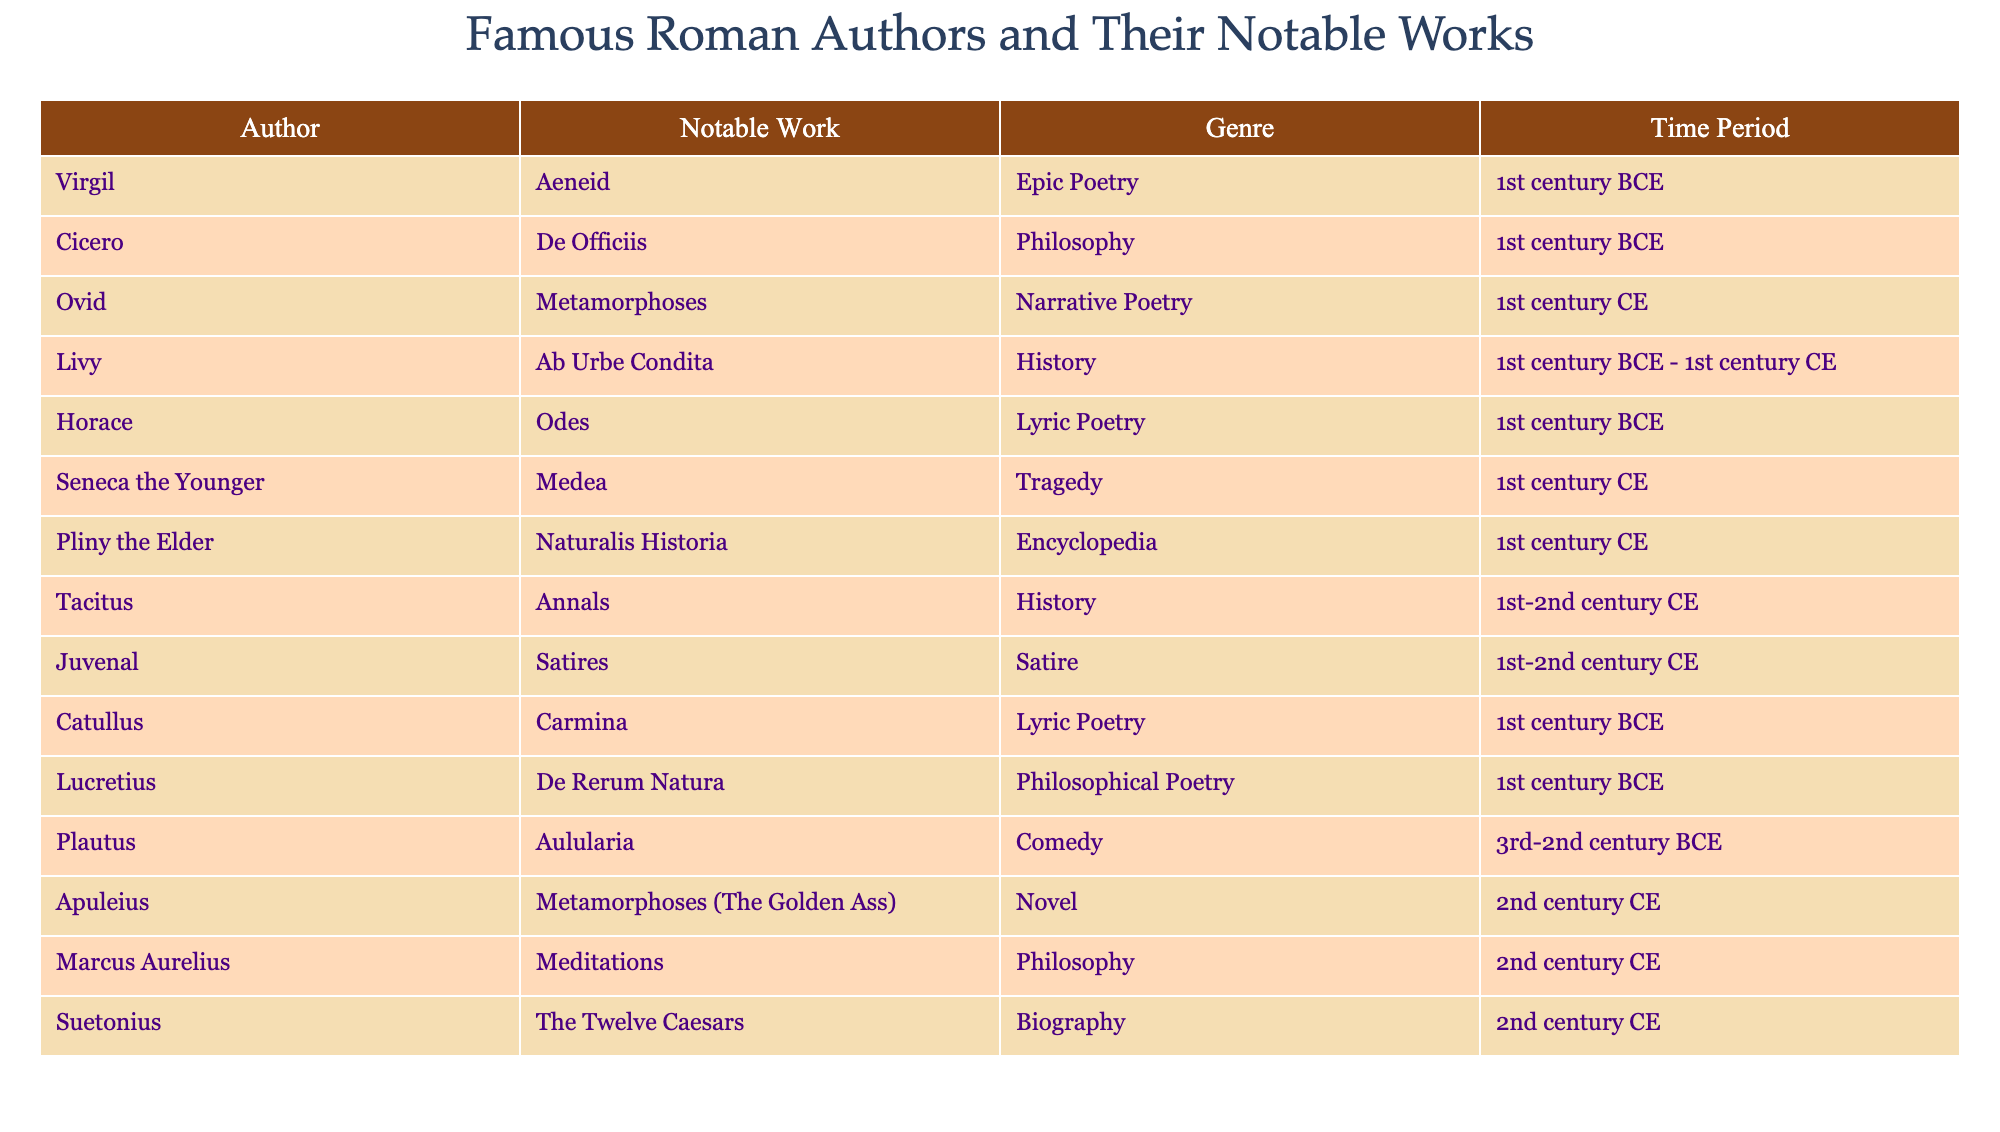What is the notable work of Virgil? The table lists the notable work associated with each author, and for Virgil, it is specifically mentioned as "Aeneid."
Answer: Aeneid Which genre does Ovid's notable work belong to? Referring to the genre column, Ovid's notable work "Metamorphoses" falls under the category "Narrative Poetry."
Answer: Narrative Poetry How many authors wrote works in the genre of Philosophy? By counting the entries in the genre column, we find that both Cicero and Marcus Aurelius are in the Philosophy category, making a total of 2 authors.
Answer: 2 Is Livy's notable work a biography? Looking at the notable work column for Livy, it states "Ab Urbe Condita," which is classified as History, not Biography, making this statement false.
Answer: No Which author has a notable work that is categorized as comedy? Referencing the table, the author Plautus is indicated as having the notable work "Aulularia," which is classified under Comedy.
Answer: Plautus What is the time period of Seneca the Younger? The table provides the time period for Seneca the Younger, which is given as "1st century CE," directly answering the question.
Answer: 1st century CE Which author has the oldest notable work and what is that work? By examining the time periods, Plautus, whose work "Aulularia" dates back to the 3rd-2nd century BCE, is the oldest, as no other works are dated earlier.
Answer: Plautus, Aulularia How many authors wrote during the 1st century CE? A review of the table shows that the following authors are from the 1st century CE: Ovid, Seneca the Younger, and Pliny the Elder, totaling 3 authors.
Answer: 3 Which genre is represented by the most authors in the table? By analyzing the genre distribution, we can see that "Lyric Poetry" and "History" both have 3 entries, making them the most represented genres.
Answer: Lyric Poetry and History 